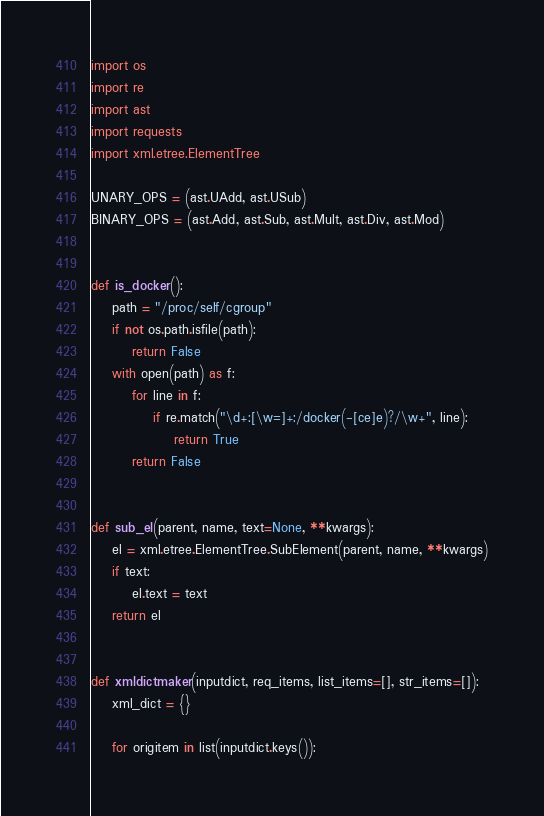Convert code to text. <code><loc_0><loc_0><loc_500><loc_500><_Python_>import os
import re
import ast
import requests
import xml.etree.ElementTree

UNARY_OPS = (ast.UAdd, ast.USub)
BINARY_OPS = (ast.Add, ast.Sub, ast.Mult, ast.Div, ast.Mod)


def is_docker():
    path = "/proc/self/cgroup"
    if not os.path.isfile(path):
        return False
    with open(path) as f:
        for line in f:
            if re.match("\d+:[\w=]+:/docker(-[ce]e)?/\w+", line):
                return True
        return False


def sub_el(parent, name, text=None, **kwargs):
    el = xml.etree.ElementTree.SubElement(parent, name, **kwargs)
    if text:
        el.text = text
    return el


def xmldictmaker(inputdict, req_items, list_items=[], str_items=[]):
    xml_dict = {}

    for origitem in list(inputdict.keys()):</code> 